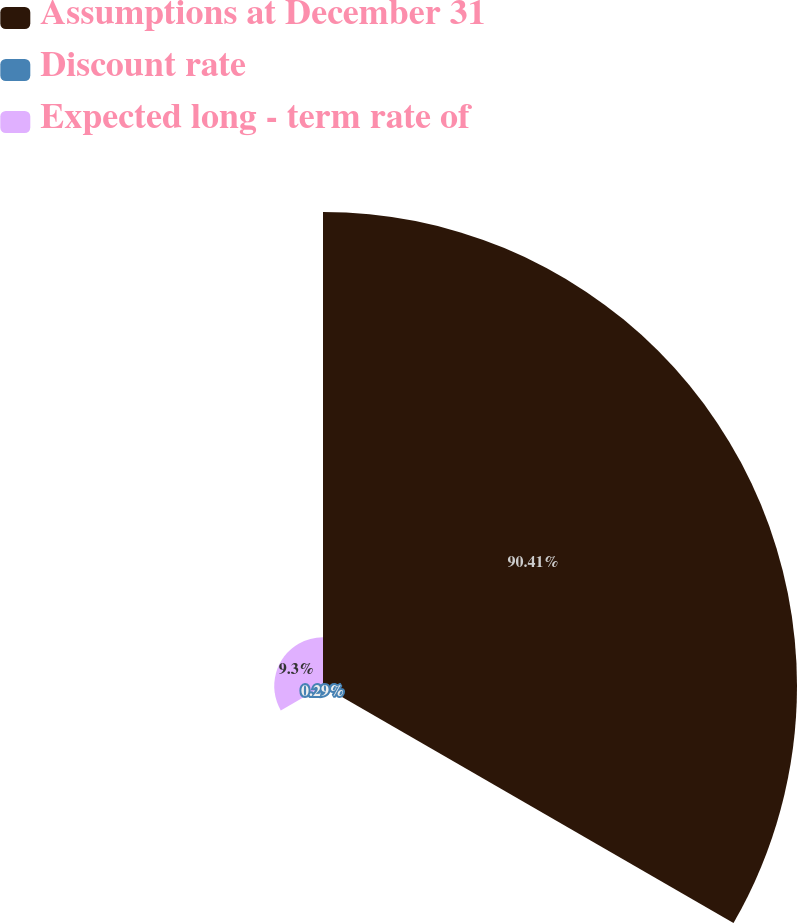Convert chart to OTSL. <chart><loc_0><loc_0><loc_500><loc_500><pie_chart><fcel>Assumptions at December 31<fcel>Discount rate<fcel>Expected long - term rate of<nl><fcel>90.41%<fcel>0.29%<fcel>9.3%<nl></chart> 